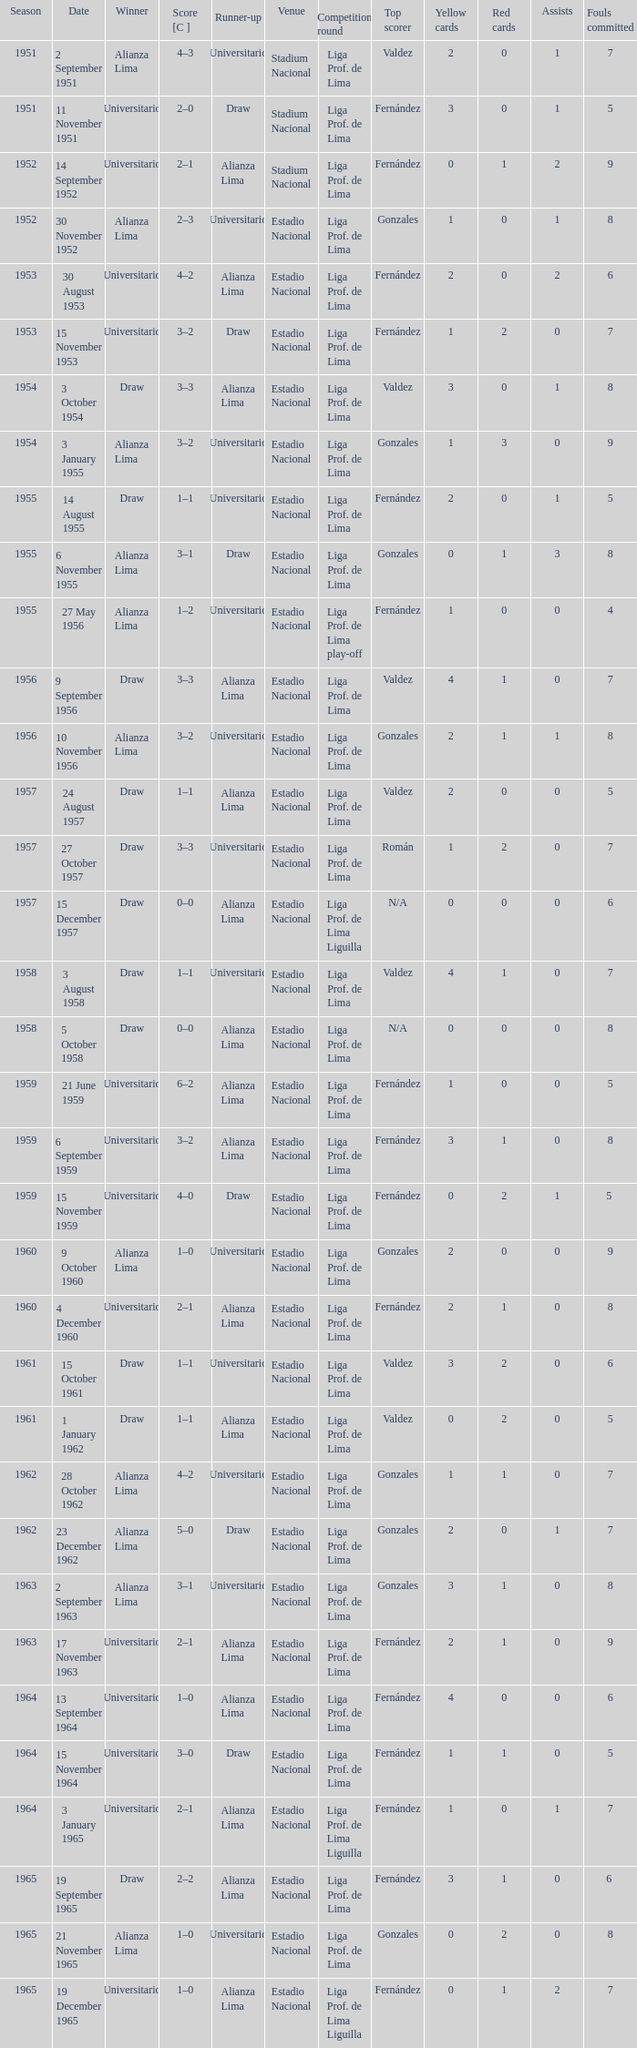Who was the winner on 15 December 1957? Draw. 